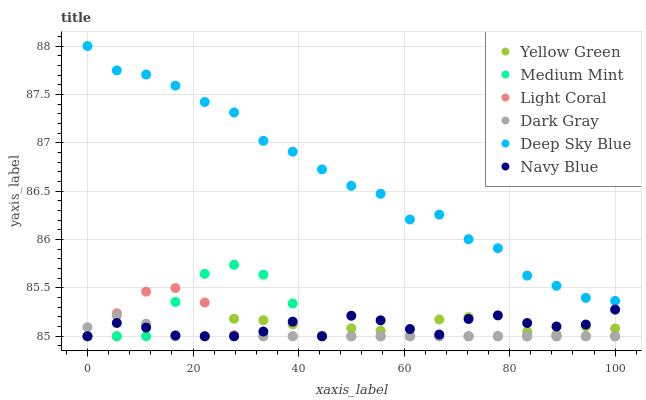Does Dark Gray have the minimum area under the curve?
Answer yes or no. Yes. Does Deep Sky Blue have the maximum area under the curve?
Answer yes or no. Yes. Does Yellow Green have the minimum area under the curve?
Answer yes or no. No. Does Yellow Green have the maximum area under the curve?
Answer yes or no. No. Is Dark Gray the smoothest?
Answer yes or no. Yes. Is Yellow Green the roughest?
Answer yes or no. Yes. Is Yellow Green the smoothest?
Answer yes or no. No. Is Dark Gray the roughest?
Answer yes or no. No. Does Medium Mint have the lowest value?
Answer yes or no. Yes. Does Deep Sky Blue have the lowest value?
Answer yes or no. No. Does Deep Sky Blue have the highest value?
Answer yes or no. Yes. Does Dark Gray have the highest value?
Answer yes or no. No. Is Navy Blue less than Deep Sky Blue?
Answer yes or no. Yes. Is Deep Sky Blue greater than Yellow Green?
Answer yes or no. Yes. Does Dark Gray intersect Light Coral?
Answer yes or no. Yes. Is Dark Gray less than Light Coral?
Answer yes or no. No. Is Dark Gray greater than Light Coral?
Answer yes or no. No. Does Navy Blue intersect Deep Sky Blue?
Answer yes or no. No. 